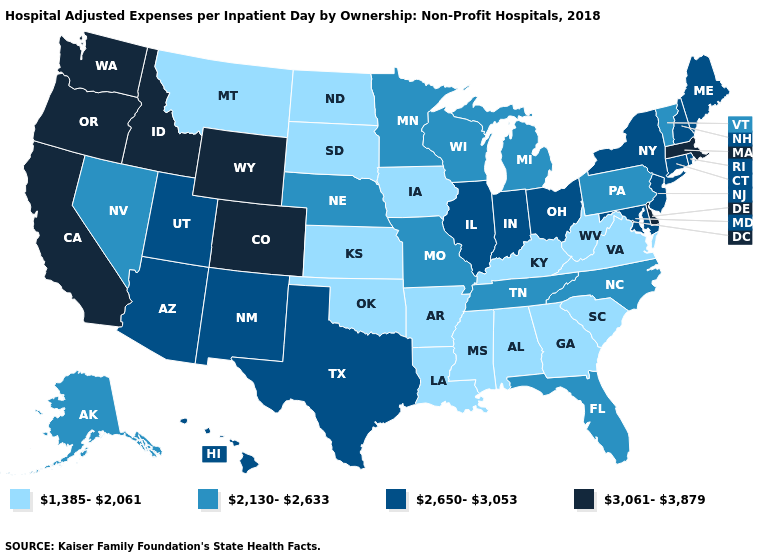Name the states that have a value in the range 2,650-3,053?
Answer briefly. Arizona, Connecticut, Hawaii, Illinois, Indiana, Maine, Maryland, New Hampshire, New Jersey, New Mexico, New York, Ohio, Rhode Island, Texas, Utah. How many symbols are there in the legend?
Short answer required. 4. What is the lowest value in states that border Nebraska?
Give a very brief answer. 1,385-2,061. What is the value of Indiana?
Write a very short answer. 2,650-3,053. Does North Dakota have the lowest value in the USA?
Answer briefly. Yes. Does Colorado have the highest value in the USA?
Answer briefly. Yes. Is the legend a continuous bar?
Be succinct. No. Does Delaware have the highest value in the USA?
Keep it brief. Yes. What is the lowest value in the Northeast?
Quick response, please. 2,130-2,633. Which states have the lowest value in the South?
Concise answer only. Alabama, Arkansas, Georgia, Kentucky, Louisiana, Mississippi, Oklahoma, South Carolina, Virginia, West Virginia. What is the lowest value in states that border Nebraska?
Write a very short answer. 1,385-2,061. What is the highest value in states that border Utah?
Give a very brief answer. 3,061-3,879. Does Wyoming have the lowest value in the West?
Give a very brief answer. No. Name the states that have a value in the range 2,650-3,053?
Concise answer only. Arizona, Connecticut, Hawaii, Illinois, Indiana, Maine, Maryland, New Hampshire, New Jersey, New Mexico, New York, Ohio, Rhode Island, Texas, Utah. What is the value of Maine?
Be succinct. 2,650-3,053. 